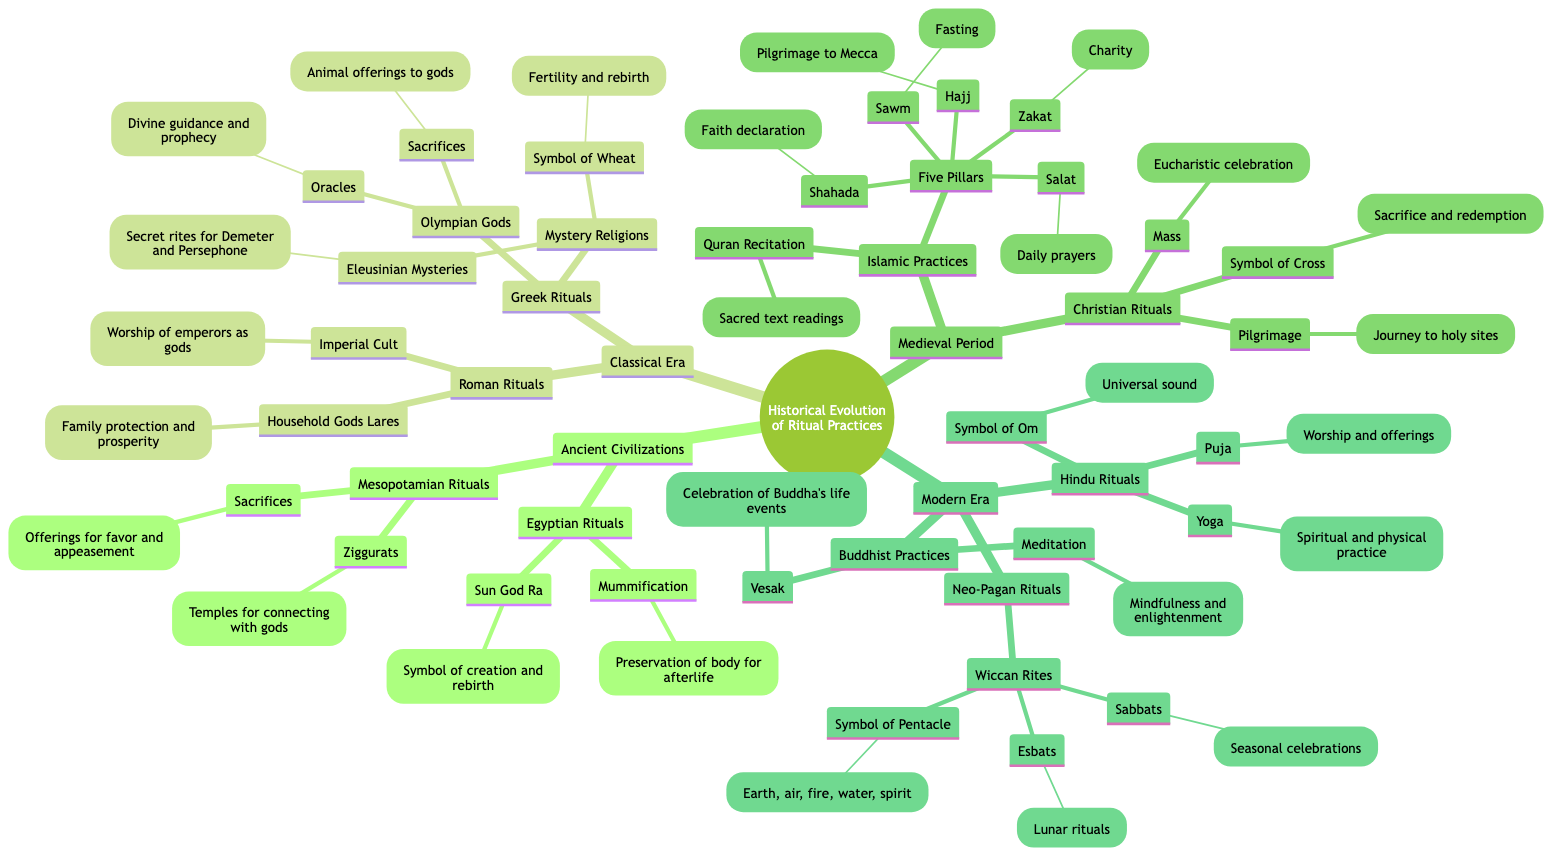What major ritual practice is associated with the Egyptian civilization? The diagram identifies Mummification as a key ritual practice under Egyptian Rituals, indicating its significance within the context of the civilization’s beliefs about the afterlife.
Answer: Mummification What are the Five Pillars of Islamic Practices? The diagram lists Shahada, Salat, Zakat, Sawm, and Hajj as the Five Pillars, which represent the fundamental acts of worship in Islam.
Answer: Shahada, Salat, Zakat, Sawm, Hajj How many major historical periods are represented in the diagram? By counting the main categories of the concept map, we identify four periods: Ancient Civilizations, Classical Era, Medieval Period, and Modern Era.
Answer: 4 What symbolic meaning is associated with the symbol of the Cross in Christian rituals? The diagram specifies that the Symbol of Cross signifies Sacrifice and redemption, illustrating its central theme in Christian worship practices.
Answer: Sacrifice and redemption Which Greek ritual is connected to divine guidance? In the Greek Rituals section, the Oracles are explicitly mentioned, indicating their role in providing divine guidance.
Answer: Oracles What is the connection between the Eleusinian Mysteries and agricultural cycles? The diagram links the Eleusinian Mysteries to the Symbol of Wheat, which represents fertility and rebirth, indicating the agricultural significance of these mystery rites.
Answer: Symbol of Wheat How does Ziggurat function in Mesopotamian rituals? The diagram describes Ziggurats as Temples for connecting with gods, showcasing their role in religious practices aimed at divine engagement in the Mesopotamian context.
Answer: Temples for connecting with gods What symbolic meaning does the Om represent in Hindu rituals? The diagram indicates that the Symbol of Om embodies the Universal sound, which highlights its significance in Hindu spiritual philosophy.
Answer: Universal sound Which ritual represents spiritual devotion and penance in the Medieval Period? The Pilgrimage is noted in Christian Rituals within the Medieval Period, demonstrating its role as an expression of spiritual devotion and penance amongst followers.
Answer: Pilgrimage 